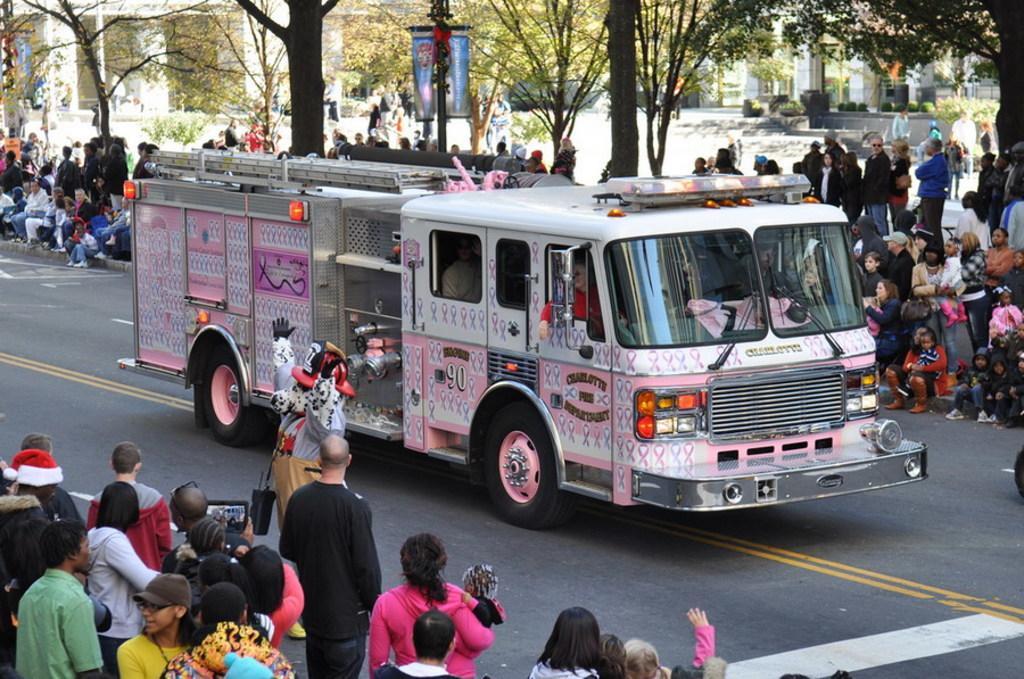In one or two sentences, can you explain what this image depicts? In this image we can see a bus moving on the road which is in pink and white color. To the both sides of the road people are standing and sitting. Background of the image trees, buildings and plants are present. 